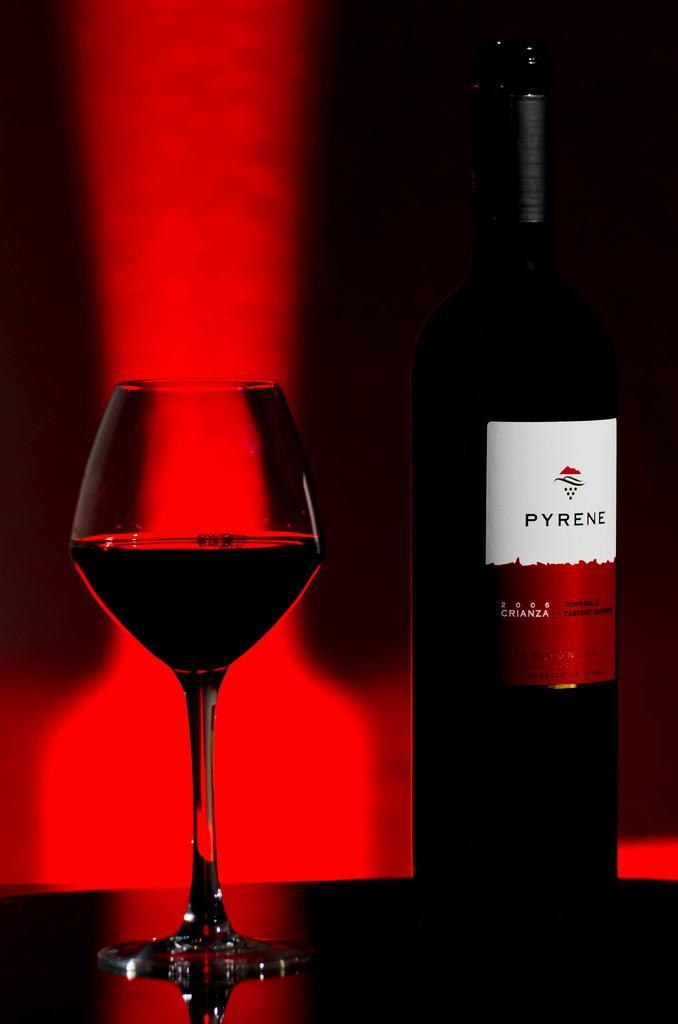Please provide a concise description of this image. In this image in the front there is a glass and there is a bottle with some text written on it. 